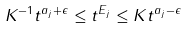<formula> <loc_0><loc_0><loc_500><loc_500>K ^ { - 1 } t ^ { a _ { j } + \epsilon } \leq \| t ^ { E _ { j } } \| \leq K t ^ { a _ { j } - \epsilon }</formula> 